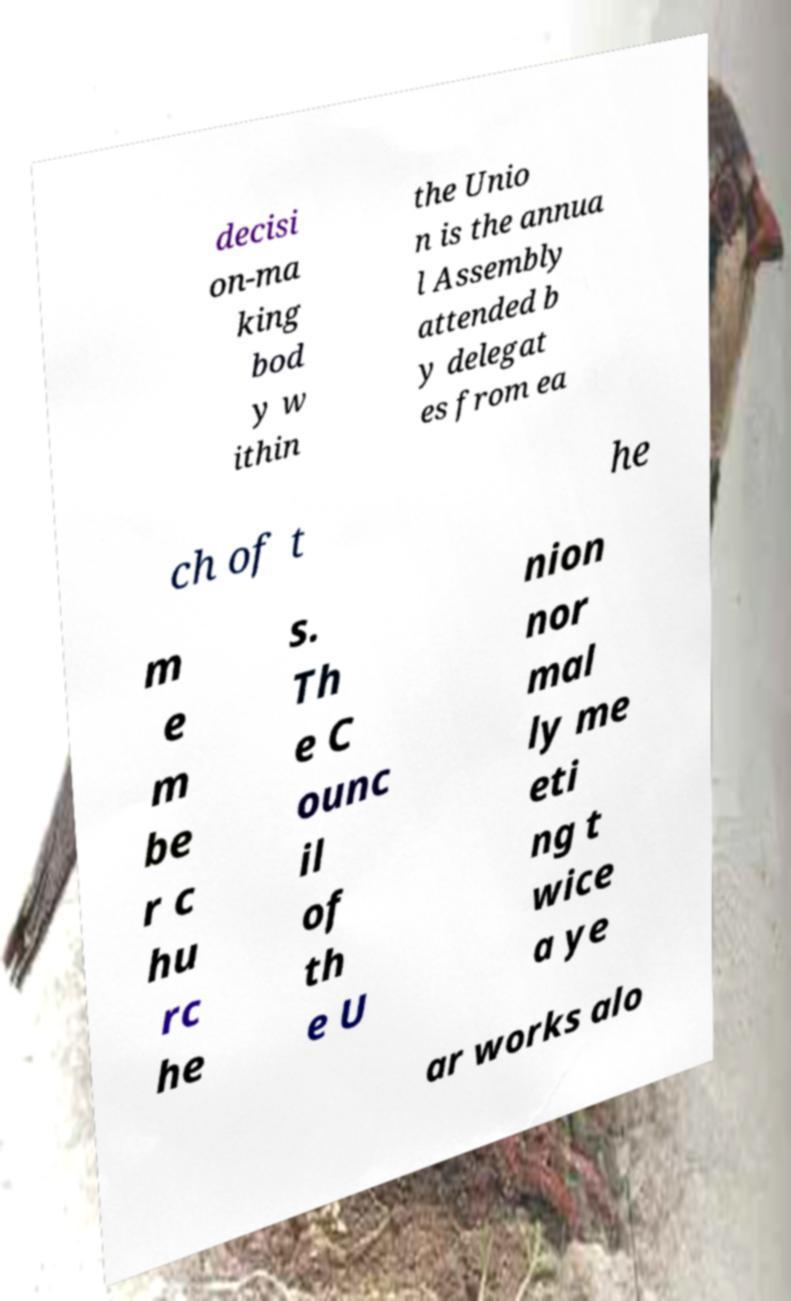There's text embedded in this image that I need extracted. Can you transcribe it verbatim? decisi on-ma king bod y w ithin the Unio n is the annua l Assembly attended b y delegat es from ea ch of t he m e m be r c hu rc he s. Th e C ounc il of th e U nion nor mal ly me eti ng t wice a ye ar works alo 